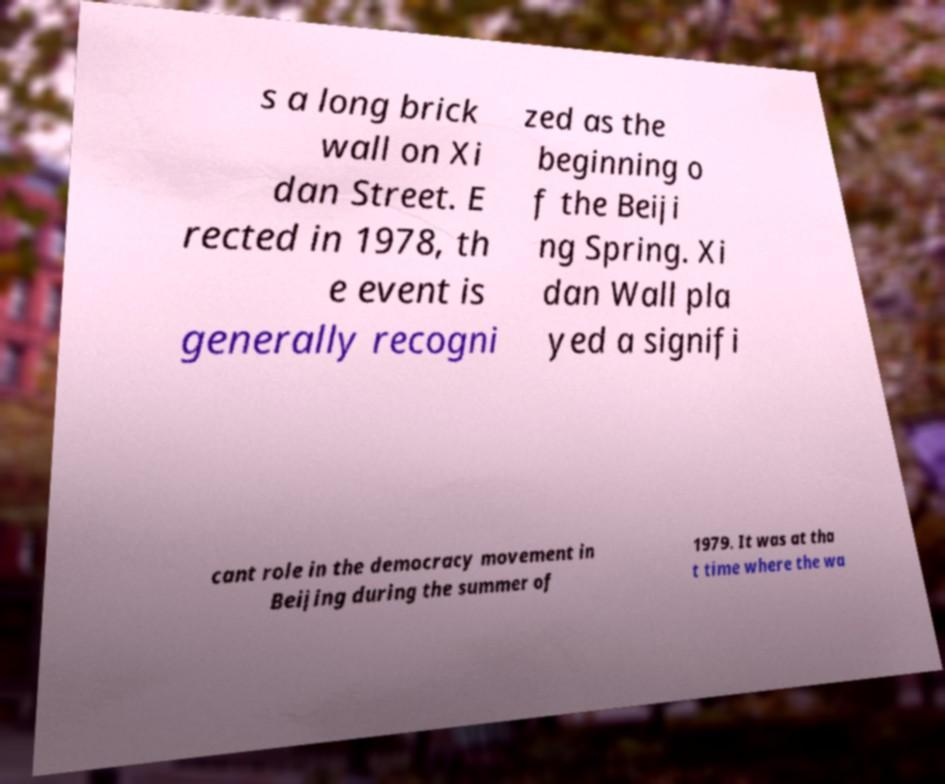Could you assist in decoding the text presented in this image and type it out clearly? s a long brick wall on Xi dan Street. E rected in 1978, th e event is generally recogni zed as the beginning o f the Beiji ng Spring. Xi dan Wall pla yed a signifi cant role in the democracy movement in Beijing during the summer of 1979. It was at tha t time where the wa 